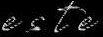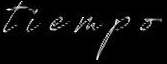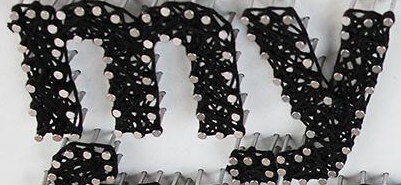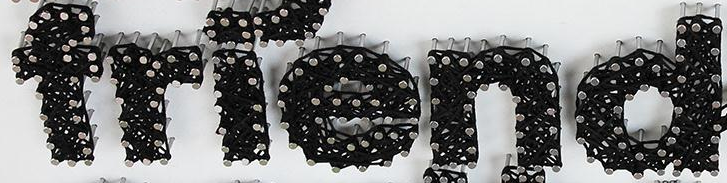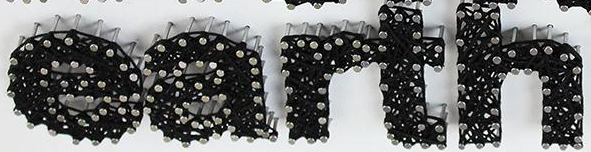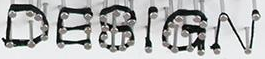Identify the words shown in these images in order, separated by a semicolon. este; tiempo; my; friend; earth; DESIGN 